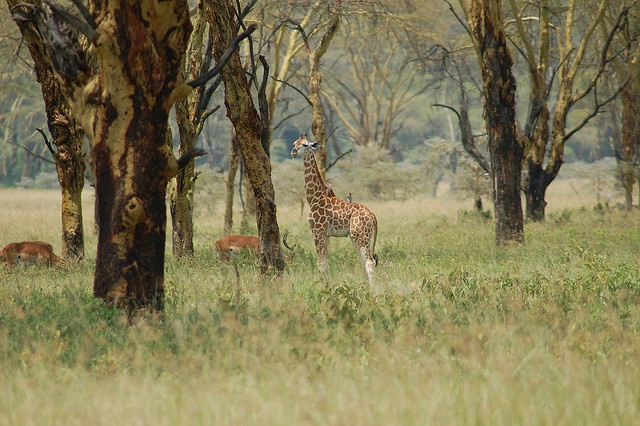Describe the objects in this image and their specific colors. I can see a giraffe in olive, tan, maroon, and gray tones in this image. 